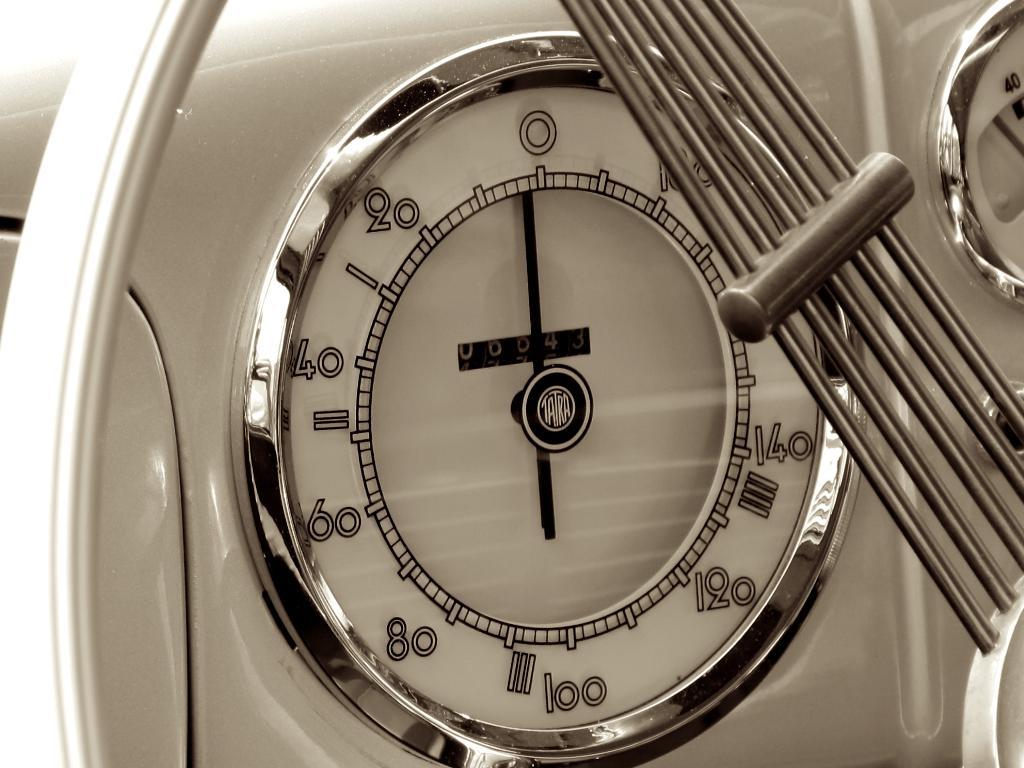What is the gauge pointing at?
Your answer should be very brief. 0. 